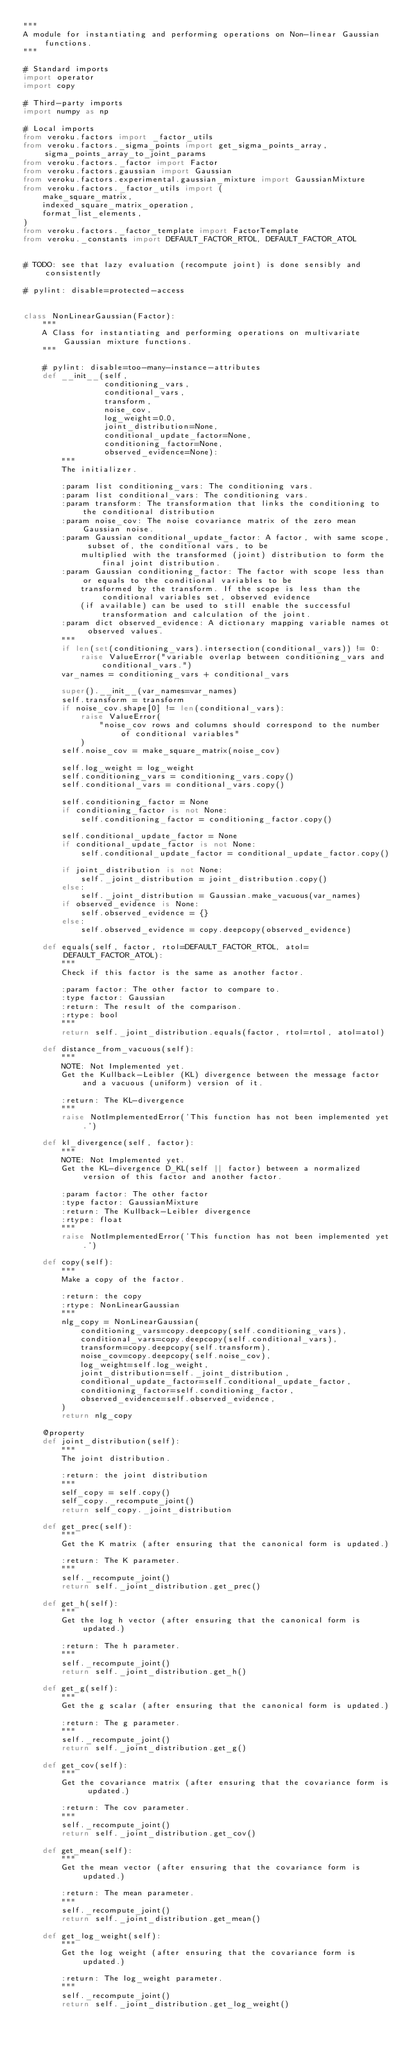<code> <loc_0><loc_0><loc_500><loc_500><_Python_>"""
A module for instantiating and performing operations on Non-linear Gaussian functions.
"""

# Standard imports
import operator
import copy

# Third-party imports
import numpy as np

# Local imports
from veroku.factors import _factor_utils
from veroku.factors._sigma_points import get_sigma_points_array, sigma_points_array_to_joint_params
from veroku.factors._factor import Factor
from veroku.factors.gaussian import Gaussian
from veroku.factors.experimental.gaussian_mixture import GaussianMixture
from veroku.factors._factor_utils import (
    make_square_matrix,
    indexed_square_matrix_operation,
    format_list_elements,
)
from veroku.factors._factor_template import FactorTemplate
from veroku._constants import DEFAULT_FACTOR_RTOL, DEFAULT_FACTOR_ATOL


# TODO: see that lazy evaluation (recompute joint) is done sensibly and consistently

# pylint: disable=protected-access


class NonLinearGaussian(Factor):
    """
    A Class for instantiating and performing operations on multivariate Gaussian mixture functions.
    """

    # pylint: disable=too-many-instance-attributes
    def __init__(self,
                 conditioning_vars,
                 conditional_vars,
                 transform,
                 noise_cov,
                 log_weight=0.0,
                 joint_distribution=None,
                 conditional_update_factor=None,
                 conditioning_factor=None,
                 observed_evidence=None):
        """
        The initializer.

        :param list conditioning_vars: The conditioning vars.
        :param list conditional_vars: The conditioning vars.
        :param transform: The transformation that links the conditioning to the conditional distribution
        :param noise_cov: The noise covariance matrix of the zero mean Gaussian noise.
        :param Gaussian conditional_update_factor: A factor, with same scope, subset of, the conditional vars, to be
            multiplied with the transformed (joint) distribution to form the final joint distribution.
        :param Gaussian conditioning_factor: The factor with scope less than or equals to the conditional variables to be
            transformed by the transform. If the scope is less than the conditional variables set, observed evidence
            (if available) can be used to still enable the successful transformation and calculation of the joint.
        :param dict observed_evidence: A dictionary mapping variable names ot observed values.
        """
        if len(set(conditioning_vars).intersection(conditional_vars)) != 0:
            raise ValueError("variable overlap between conditioning_vars and conditional_vars.")
        var_names = conditioning_vars + conditional_vars

        super().__init__(var_names=var_names)
        self.transform = transform
        if noise_cov.shape[0] != len(conditional_vars):
            raise ValueError(
                "noise_cov rows and columns should correspond to the number of conditional variables"
            )
        self.noise_cov = make_square_matrix(noise_cov)

        self.log_weight = log_weight
        self.conditioning_vars = conditioning_vars.copy()
        self.conditional_vars = conditional_vars.copy()

        self.conditioning_factor = None
        if conditioning_factor is not None:
            self.conditioning_factor = conditioning_factor.copy()

        self.conditional_update_factor = None
        if conditional_update_factor is not None:
            self.conditional_update_factor = conditional_update_factor.copy()

        if joint_distribution is not None:
            self._joint_distribution = joint_distribution.copy()
        else:
            self._joint_distribution = Gaussian.make_vacuous(var_names)
        if observed_evidence is None:
            self.observed_evidence = {}
        else:
            self.observed_evidence = copy.deepcopy(observed_evidence)

    def equals(self, factor, rtol=DEFAULT_FACTOR_RTOL, atol=DEFAULT_FACTOR_ATOL):
        """
        Check if this factor is the same as another factor.

        :param factor: The other factor to compare to.
        :type factor: Gaussian
        :return: The result of the comparison.
        :rtype: bool
        """
        return self._joint_distribution.equals(factor, rtol=rtol, atol=atol)

    def distance_from_vacuous(self):
        """
        NOTE: Not Implemented yet.
        Get the Kullback-Leibler (KL) divergence between the message factor and a vacuous (uniform) version of it.

        :return: The KL-divergence
        """
        raise NotImplementedError('This function has not been implemented yet.')

    def kl_divergence(self, factor):
        """
        NOTE: Not Implemented yet.
        Get the KL-divergence D_KL(self || factor) between a normalized version of this factor and another factor.

        :param factor: The other factor
        :type factor: GaussianMixture
        :return: The Kullback-Leibler divergence
        :rtype: float
        """
        raise NotImplementedError('This function has not been implemented yet.')

    def copy(self):
        """
        Make a copy of the factor.

        :return: the copy
        :rtype: NonLinearGaussian
        """
        nlg_copy = NonLinearGaussian(
            conditioning_vars=copy.deepcopy(self.conditioning_vars),
            conditional_vars=copy.deepcopy(self.conditional_vars),
            transform=copy.deepcopy(self.transform),
            noise_cov=copy.deepcopy(self.noise_cov),
            log_weight=self.log_weight,
            joint_distribution=self._joint_distribution,
            conditional_update_factor=self.conditional_update_factor,
            conditioning_factor=self.conditioning_factor,
            observed_evidence=self.observed_evidence,
        )
        return nlg_copy

    @property
    def joint_distribution(self):
        """
        The joint distribution.

        :return: the joint distribution
        """
        self_copy = self.copy()
        self_copy._recompute_joint()
        return self_copy._joint_distribution

    def get_prec(self):
        """
        Get the K matrix (after ensuring that the canonical form is updated.)

        :return: The K parameter.
        """
        self._recompute_joint()
        return self._joint_distribution.get_prec()

    def get_h(self):
        """
        Get the log h vector (after ensuring that the canonical form is updated.)

        :return: The h parameter.
        """
        self._recompute_joint()
        return self._joint_distribution.get_h()

    def get_g(self):
        """
        Get the g scalar (after ensuring that the canonical form is updated.)

        :return: The g parameter.
        """
        self._recompute_joint()
        return self._joint_distribution.get_g()

    def get_cov(self):
        """
        Get the covariance matrix (after ensuring that the covariance form is updated.)

        :return: The cov parameter.
        """
        self._recompute_joint()
        return self._joint_distribution.get_cov()

    def get_mean(self):
        """
        Get the mean vector (after ensuring that the covariance form is updated.)

        :return: The mean parameter.
        """
        self._recompute_joint()
        return self._joint_distribution.get_mean()

    def get_log_weight(self):
        """
        Get the log weight (after ensuring that the covariance form is updated.)

        :return: The log_weight parameter.
        """
        self._recompute_joint()
        return self._joint_distribution.get_log_weight()
</code> 